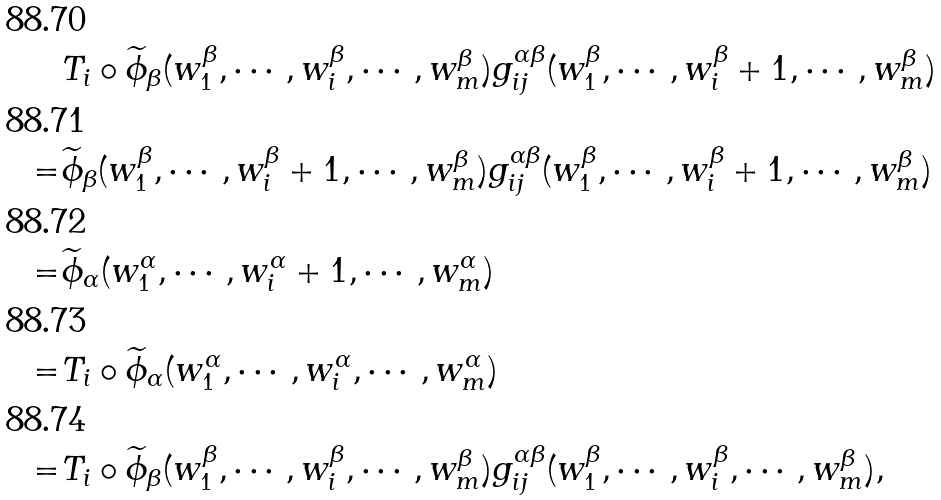<formula> <loc_0><loc_0><loc_500><loc_500>& T _ { i } \circ \widetilde { \phi } _ { \beta } ( w _ { 1 } ^ { \beta } , \cdots , w _ { i } ^ { \beta } , \cdots , w _ { m } ^ { \beta } ) g _ { i j } ^ { \alpha \beta } ( w _ { 1 } ^ { \beta } , \cdots , w _ { i } ^ { \beta } + 1 , \cdots , w _ { m } ^ { \beta } ) \\ = & \widetilde { \phi } _ { \beta } ( w _ { 1 } ^ { \beta } , \cdots , w _ { i } ^ { \beta } + 1 , \cdots , w _ { m } ^ { \beta } ) g _ { i j } ^ { \alpha \beta } ( w _ { 1 } ^ { \beta } , \cdots , w _ { i } ^ { \beta } + 1 , \cdots , w _ { m } ^ { \beta } ) \\ = & \widetilde { \phi } _ { \alpha } ( w _ { 1 } ^ { \alpha } , \cdots , w _ { i } ^ { \alpha } + 1 , \cdots , w _ { m } ^ { \alpha } ) \\ = & T _ { i } \circ \widetilde { \phi } _ { \alpha } ( w _ { 1 } ^ { \alpha } , \cdots , w _ { i } ^ { \alpha } , \cdots , w _ { m } ^ { \alpha } ) \\ = & T _ { i } \circ \widetilde { \phi } _ { \beta } ( w _ { 1 } ^ { \beta } , \cdots , w _ { i } ^ { \beta } , \cdots , w _ { m } ^ { \beta } ) g _ { i j } ^ { \alpha \beta } ( w _ { 1 } ^ { \beta } , \cdots , w _ { i } ^ { \beta } , \cdots , w _ { m } ^ { \beta } ) ,</formula> 